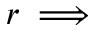<formula> <loc_0><loc_0><loc_500><loc_500>r \implies</formula> 